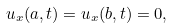Convert formula to latex. <formula><loc_0><loc_0><loc_500><loc_500>u _ { x } ( a , t ) = u _ { x } ( b , t ) = 0 ,</formula> 